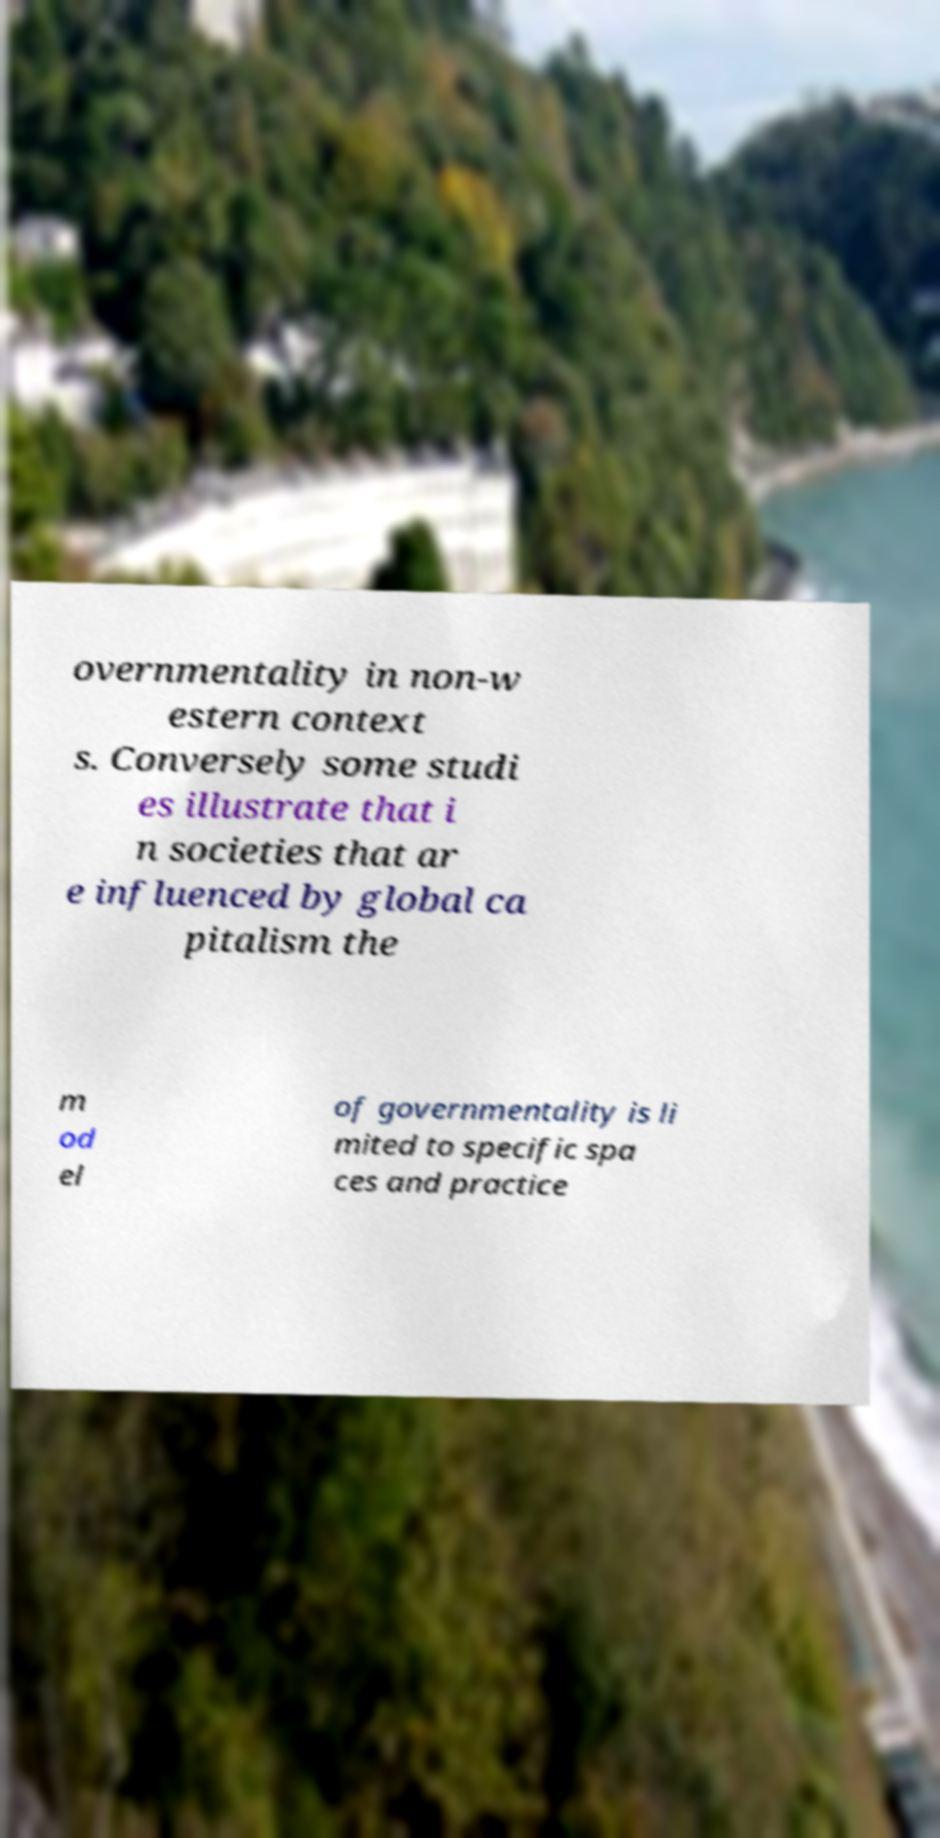Could you extract and type out the text from this image? overnmentality in non-w estern context s. Conversely some studi es illustrate that i n societies that ar e influenced by global ca pitalism the m od el of governmentality is li mited to specific spa ces and practice 